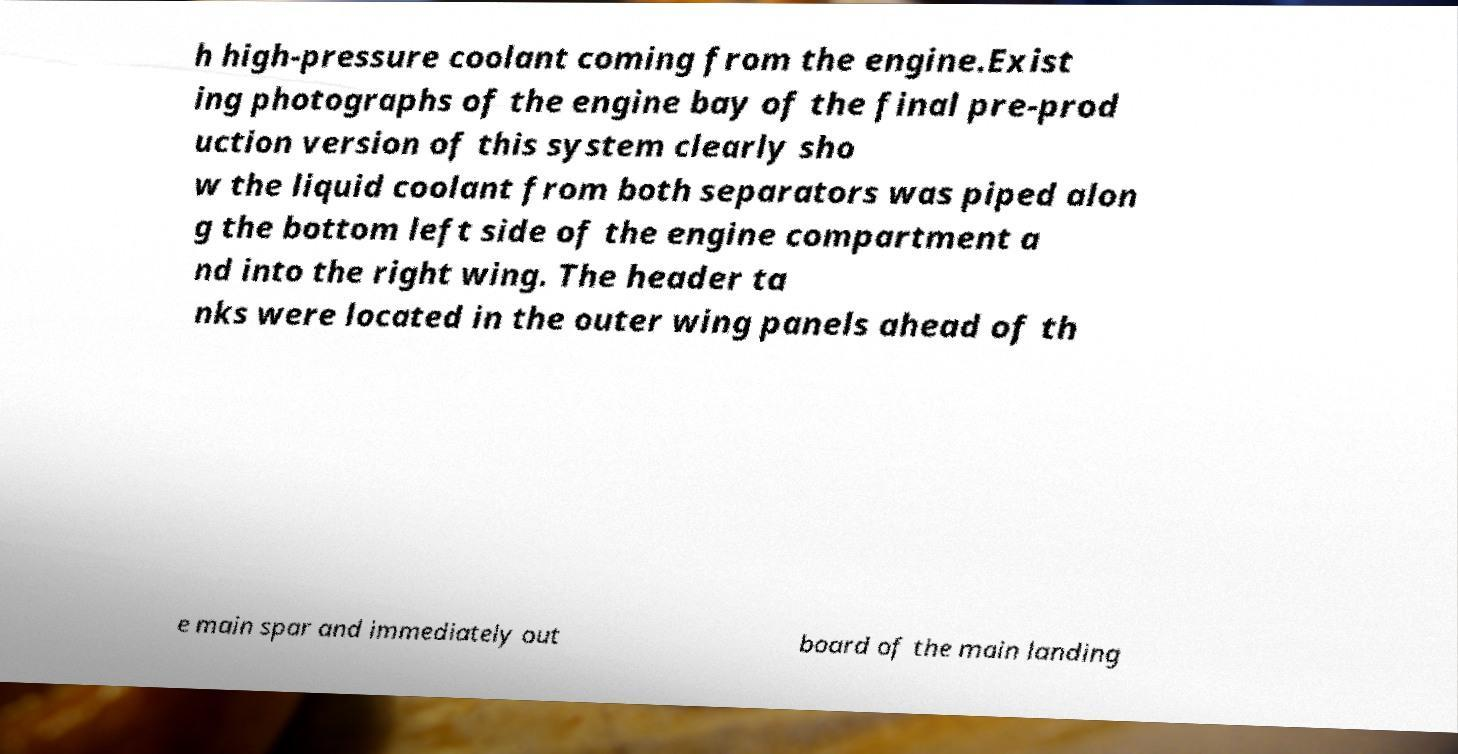Please identify and transcribe the text found in this image. h high-pressure coolant coming from the engine.Exist ing photographs of the engine bay of the final pre-prod uction version of this system clearly sho w the liquid coolant from both separators was piped alon g the bottom left side of the engine compartment a nd into the right wing. The header ta nks were located in the outer wing panels ahead of th e main spar and immediately out board of the main landing 